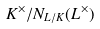<formula> <loc_0><loc_0><loc_500><loc_500>K ^ { \times } / N _ { L / K } ( L ^ { \times } )</formula> 